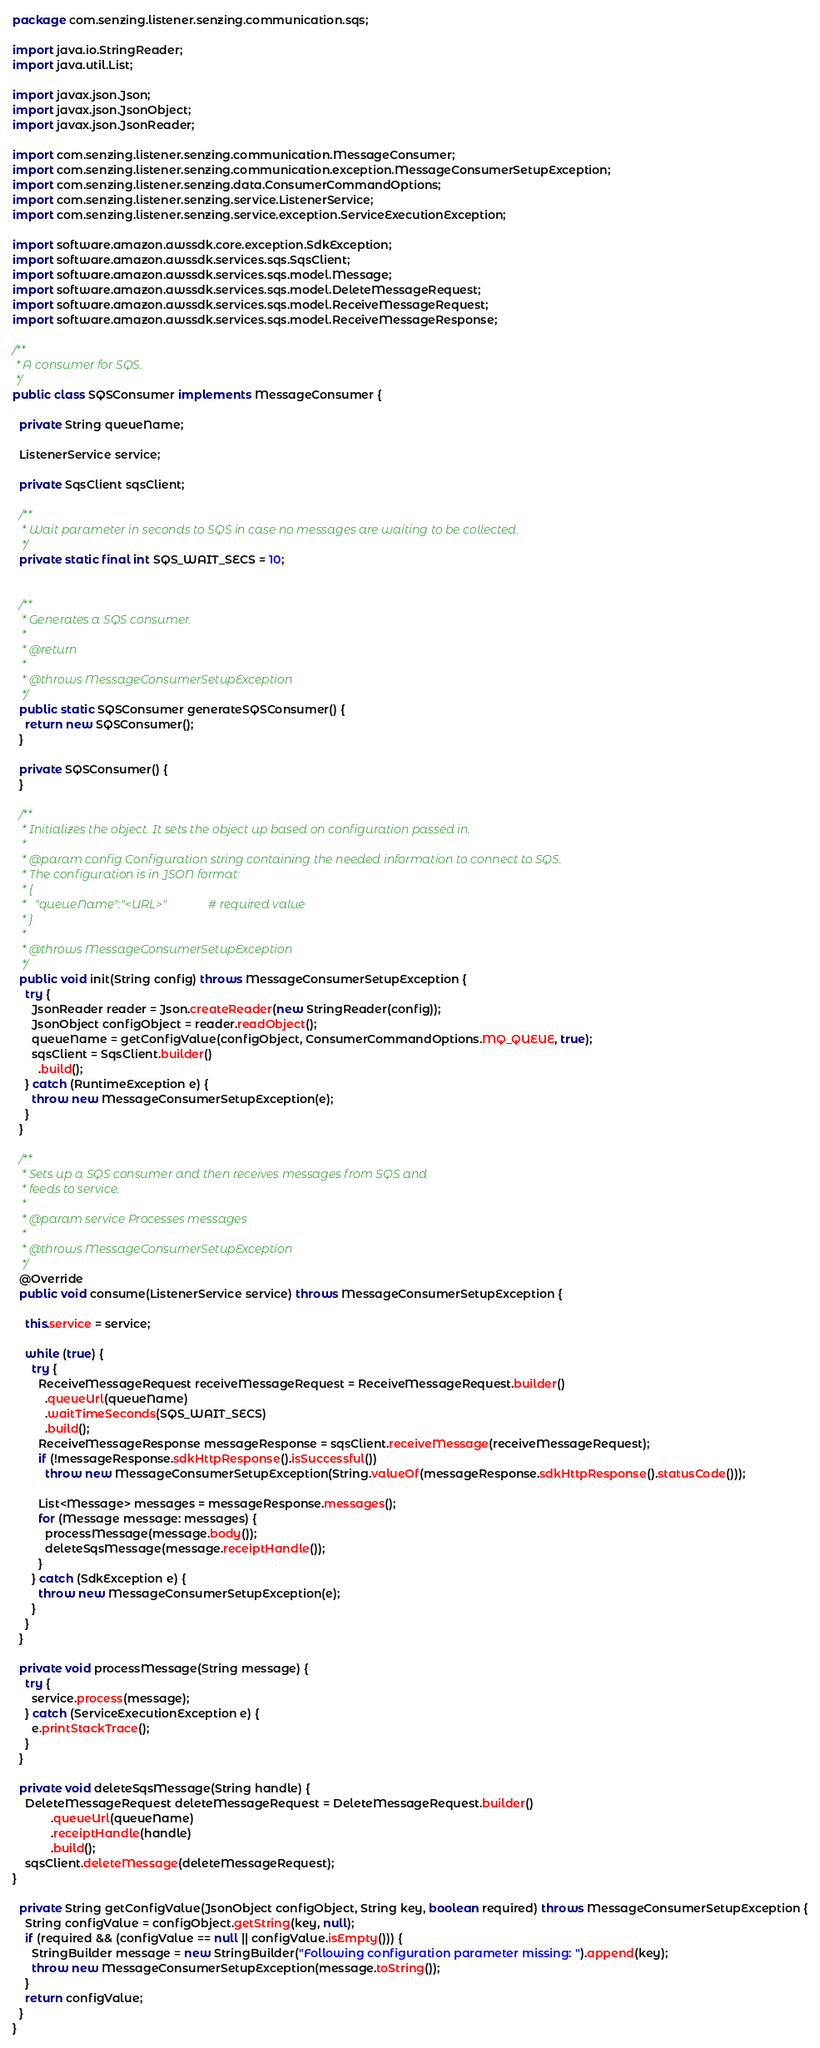Convert code to text. <code><loc_0><loc_0><loc_500><loc_500><_Java_>package com.senzing.listener.senzing.communication.sqs;

import java.io.StringReader;
import java.util.List;

import javax.json.Json;
import javax.json.JsonObject;
import javax.json.JsonReader;

import com.senzing.listener.senzing.communication.MessageConsumer;
import com.senzing.listener.senzing.communication.exception.MessageConsumerSetupException;
import com.senzing.listener.senzing.data.ConsumerCommandOptions;
import com.senzing.listener.senzing.service.ListenerService;
import com.senzing.listener.senzing.service.exception.ServiceExecutionException;

import software.amazon.awssdk.core.exception.SdkException;
import software.amazon.awssdk.services.sqs.SqsClient;
import software.amazon.awssdk.services.sqs.model.Message;
import software.amazon.awssdk.services.sqs.model.DeleteMessageRequest;
import software.amazon.awssdk.services.sqs.model.ReceiveMessageRequest;
import software.amazon.awssdk.services.sqs.model.ReceiveMessageResponse;

/**
 * A consumer for SQS.
 */
public class SQSConsumer implements MessageConsumer {

  private String queueName;

  ListenerService service;

  private SqsClient sqsClient;

  /**
   * Wait parameter in seconds to SQS in case no messages are waiting to be collected.
   */
  private static final int SQS_WAIT_SECS = 10;


  /**
   * Generates a SQS consumer.
   * 
   * @return
   * 
   * @throws MessageConsumerSetupException
   */
  public static SQSConsumer generateSQSConsumer() {
    return new SQSConsumer();
  }

  private SQSConsumer() {
  }

  /**
   * Initializes the object. It sets the object up based on configuration passed in.
   * 
   * @param config Configuration string containing the needed information to connect to SQS.
   * The configuration is in JSON format:
   * {
   *   "queueName":"<URL>"              # required value
   * }
   *
   * @throws MessageConsumerSetupException
   */
  public void init(String config) throws MessageConsumerSetupException {
    try {
      JsonReader reader = Json.createReader(new StringReader(config));
      JsonObject configObject = reader.readObject();
      queueName = getConfigValue(configObject, ConsumerCommandOptions.MQ_QUEUE, true);
      sqsClient = SqsClient.builder()
        .build();
    } catch (RuntimeException e) {
      throw new MessageConsumerSetupException(e);
    }
  }

  /**
   * Sets up a SQS consumer and then receives messages from SQS and
   * feeds to service.
   * 
   * @param service Processes messages
   * 
   * @throws MessageConsumerSetupException
   */
  @Override
  public void consume(ListenerService service) throws MessageConsumerSetupException {

    this.service = service;

    while (true) {
      try {
        ReceiveMessageRequest receiveMessageRequest = ReceiveMessageRequest.builder()
          .queueUrl(queueName)
          .waitTimeSeconds(SQS_WAIT_SECS)
          .build();
        ReceiveMessageResponse messageResponse = sqsClient.receiveMessage(receiveMessageRequest);
        if (!messageResponse.sdkHttpResponse().isSuccessful())
          throw new MessageConsumerSetupException(String.valueOf(messageResponse.sdkHttpResponse().statusCode()));

        List<Message> messages = messageResponse.messages();
        for (Message message: messages) {
          processMessage(message.body());
          deleteSqsMessage(message.receiptHandle());
        }
      } catch (SdkException e) {
        throw new MessageConsumerSetupException(e);
      }
    }
  }

  private void processMessage(String message) {
    try {
      service.process(message);
    } catch (ServiceExecutionException e) {
      e.printStackTrace();
    }
  }

  private void deleteSqsMessage(String handle) {
    DeleteMessageRequest deleteMessageRequest = DeleteMessageRequest.builder()
            .queueUrl(queueName)
            .receiptHandle(handle)
            .build();
    sqsClient.deleteMessage(deleteMessageRequest);
}

  private String getConfigValue(JsonObject configObject, String key, boolean required) throws MessageConsumerSetupException {
    String configValue = configObject.getString(key, null);
    if (required && (configValue == null || configValue.isEmpty())) {
      StringBuilder message = new StringBuilder("Following configuration parameter missing: ").append(key);
      throw new MessageConsumerSetupException(message.toString());
    }
    return configValue;
  }
}
</code> 